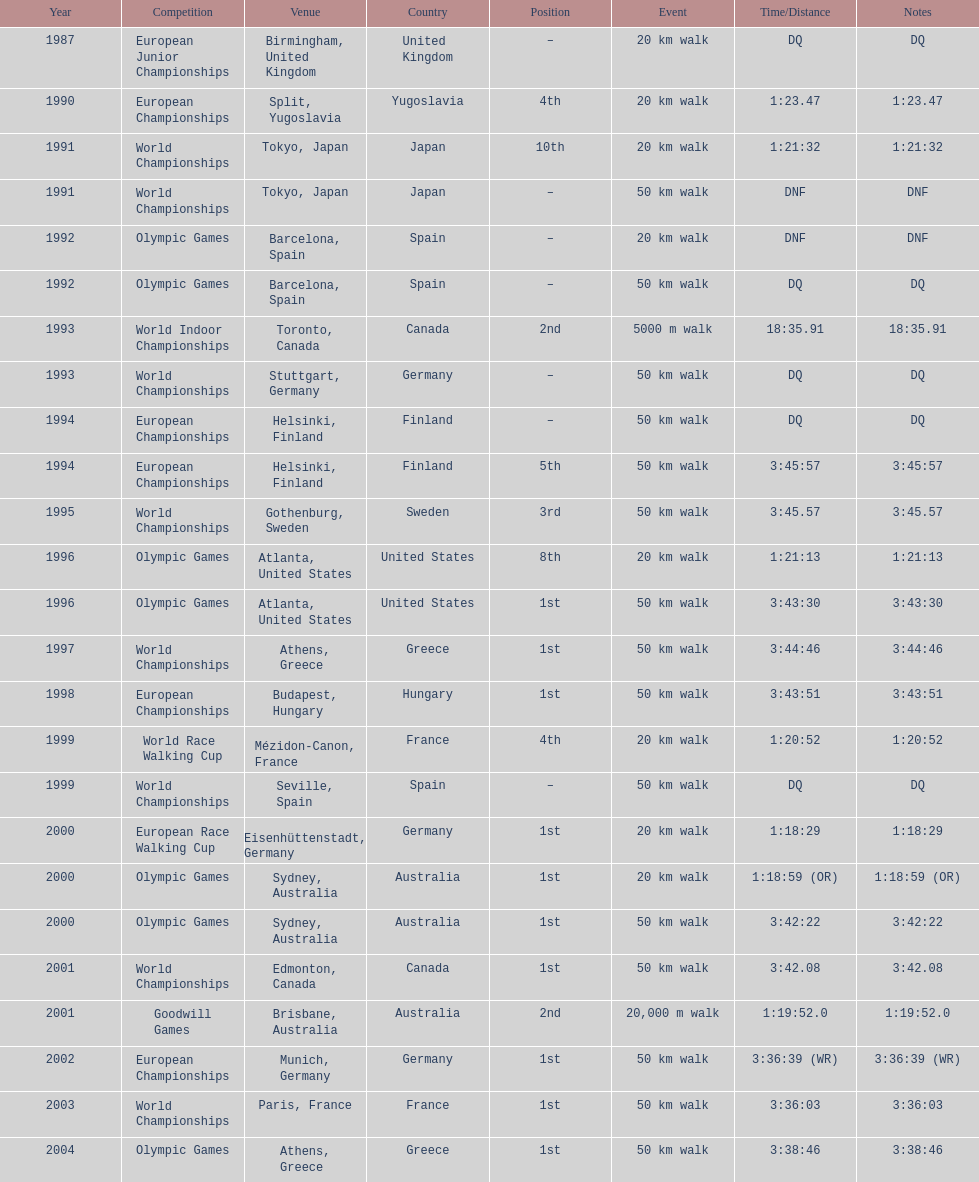What was the difference between korzeniowski's performance at the 1996 olympic games and the 2000 olympic games in the 20 km walk? 2:14. 